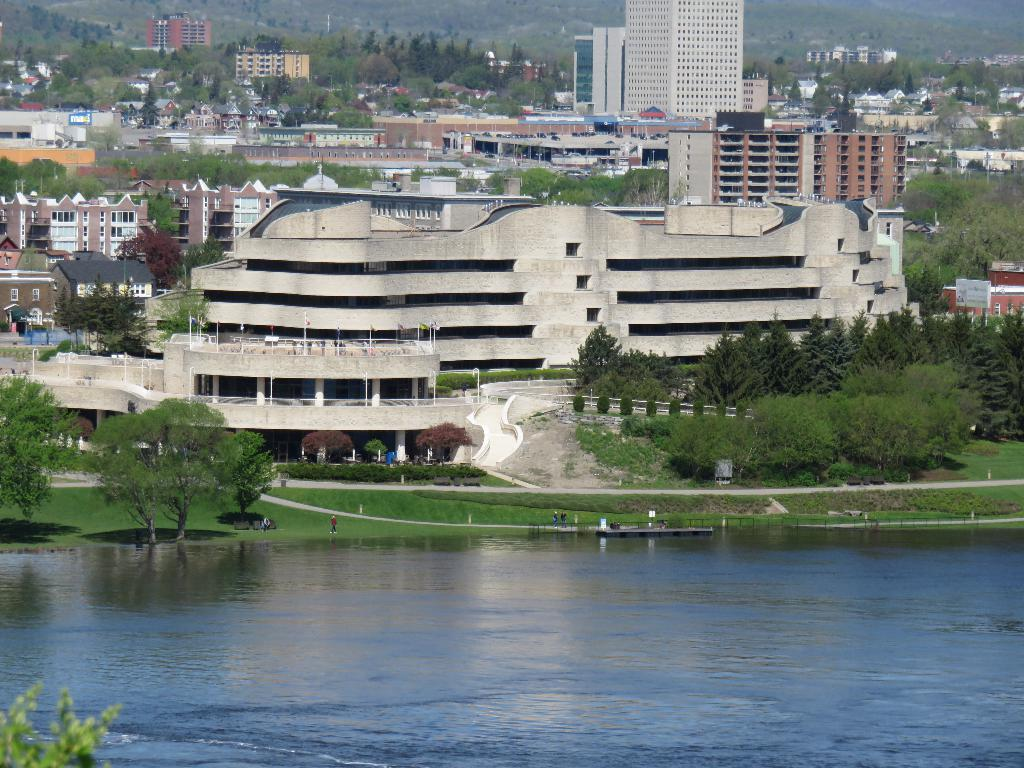What type of natural feature is present in the image? There is a lake in the image. What type of vegetation can be seen in the image? There are trees and grass visible in the image. What type of man-made structures are visible in the image? There are buildings visible in the image. What direction does the bit of love take in the image? There is no bit of love present in the image, as it is a natural scene featuring a lake, trees, grass, and buildings. 